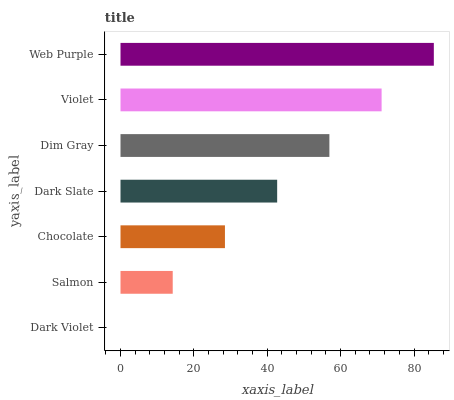Is Dark Violet the minimum?
Answer yes or no. Yes. Is Web Purple the maximum?
Answer yes or no. Yes. Is Salmon the minimum?
Answer yes or no. No. Is Salmon the maximum?
Answer yes or no. No. Is Salmon greater than Dark Violet?
Answer yes or no. Yes. Is Dark Violet less than Salmon?
Answer yes or no. Yes. Is Dark Violet greater than Salmon?
Answer yes or no. No. Is Salmon less than Dark Violet?
Answer yes or no. No. Is Dark Slate the high median?
Answer yes or no. Yes. Is Dark Slate the low median?
Answer yes or no. Yes. Is Web Purple the high median?
Answer yes or no. No. Is Dim Gray the low median?
Answer yes or no. No. 